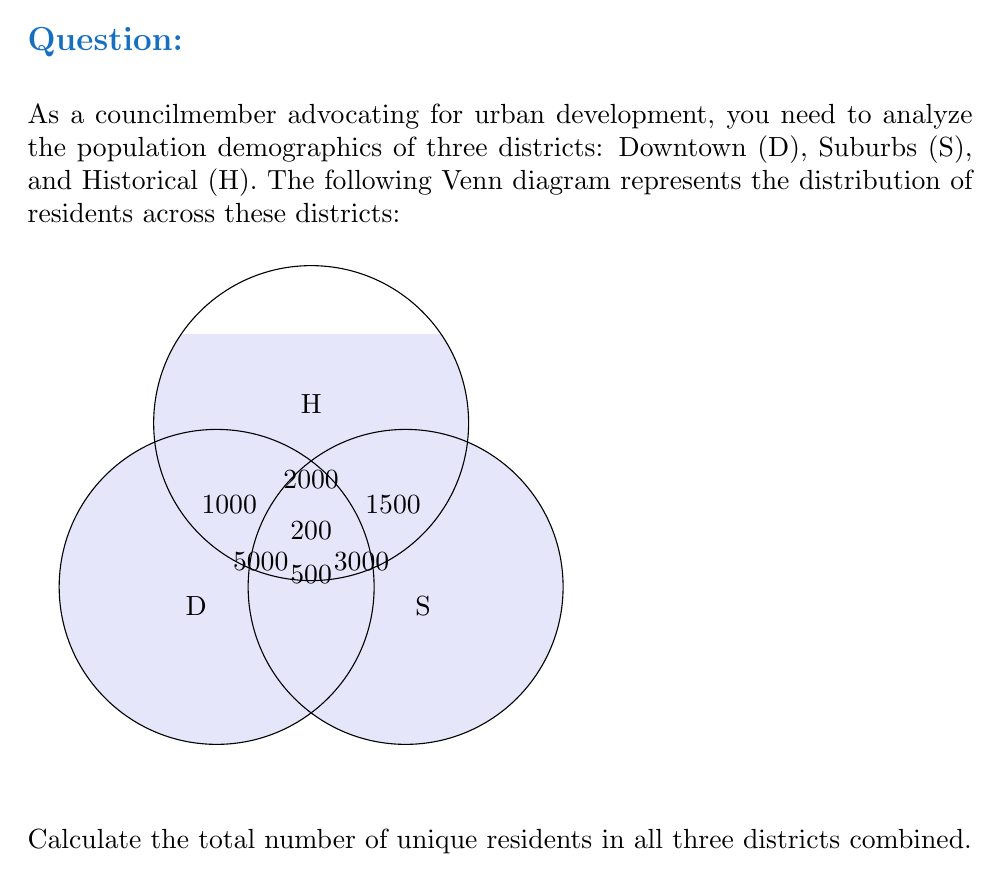Help me with this question. To find the total number of unique residents, we need to add up the population in each region of the Venn diagram, ensuring we don't count any overlapping areas more than once.

Let's break it down step-by-step:

1. Residents exclusively in Downtown (D): 5000
2. Residents exclusively in Suburbs (S): 3000
3. Residents exclusively in Historical (H): 2000
4. Residents in D ∩ S (but not in H): 500
5. Residents in D ∩ H (but not in S): 1000
6. Residents in S ∩ H (but not in D): 1500
7. Residents in D ∩ S ∩ H: 200

Now, we can use the principle of inclusion-exclusion to calculate the total:

$$\begin{align*}
|D ∪ S ∪ H| &= |D| + |S| + |H| - |D ∩ S| - |D ∩ H| - |S ∩ H| + |D ∩ S ∩ H| \\
&= (5000 + 500 + 1000 + 200) + (3000 + 500 + 1500 + 200) + (2000 + 1000 + 1500 + 200) \\
&\quad - (500 + 200) - (1000 + 200) - (1500 + 200) + 200 \\
&= 6700 + 5200 + 4700 - 700 - 1200 - 1700 + 200 \\
&= 13200
\end{align*}$$

Therefore, the total number of unique residents in all three districts is 13,200.
Answer: 13,200 